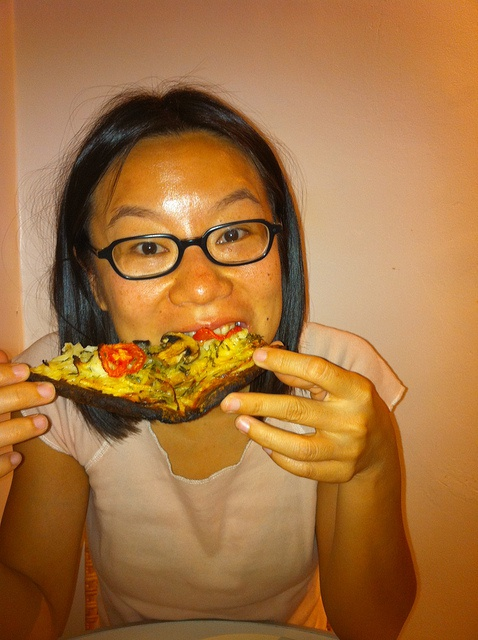Describe the objects in this image and their specific colors. I can see people in brown, maroon, black, and tan tones, pizza in brown, orange, olive, and maroon tones, and dining table in brown, olive, gray, and maroon tones in this image. 